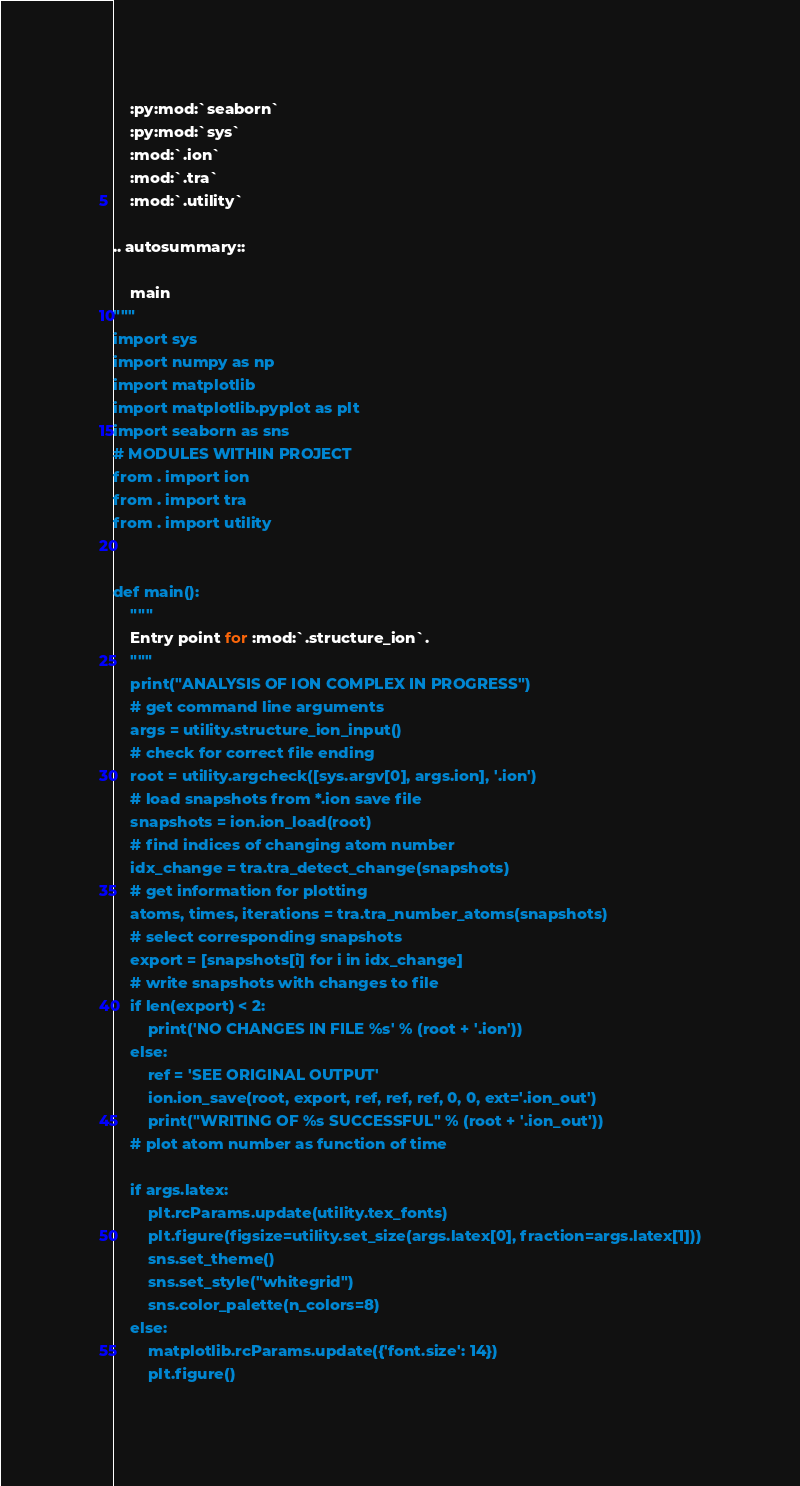Convert code to text. <code><loc_0><loc_0><loc_500><loc_500><_Python_>    :py:mod:`seaborn`
    :py:mod:`sys`
    :mod:`.ion`
    :mod:`.tra`
    :mod:`.utility`

.. autosummary::

    main
"""
import sys
import numpy as np
import matplotlib
import matplotlib.pyplot as plt
import seaborn as sns
# MODULES WITHIN PROJECT
from . import ion
from . import tra
from . import utility


def main():
    """
    Entry point for :mod:`.structure_ion`.
    """
    print("ANALYSIS OF ION COMPLEX IN PROGRESS")
    # get command line arguments
    args = utility.structure_ion_input()
    # check for correct file ending
    root = utility.argcheck([sys.argv[0], args.ion], '.ion')
    # load snapshots from *.ion save file
    snapshots = ion.ion_load(root)
    # find indices of changing atom number
    idx_change = tra.tra_detect_change(snapshots)
    # get information for plotting
    atoms, times, iterations = tra.tra_number_atoms(snapshots)
    # select corresponding snapshots
    export = [snapshots[i] for i in idx_change]
    # write snapshots with changes to file
    if len(export) < 2:
        print('NO CHANGES IN FILE %s' % (root + '.ion'))
    else:
        ref = 'SEE ORIGINAL OUTPUT'
        ion.ion_save(root, export, ref, ref, ref, 0, 0, ext='.ion_out')
        print("WRITING OF %s SUCCESSFUL" % (root + '.ion_out'))
    # plot atom number as function of time

    if args.latex:
        plt.rcParams.update(utility.tex_fonts)
        plt.figure(figsize=utility.set_size(args.latex[0], fraction=args.latex[1]))
        sns.set_theme()
        sns.set_style("whitegrid")
        sns.color_palette(n_colors=8)
    else:
        matplotlib.rcParams.update({'font.size': 14})
        plt.figure()</code> 